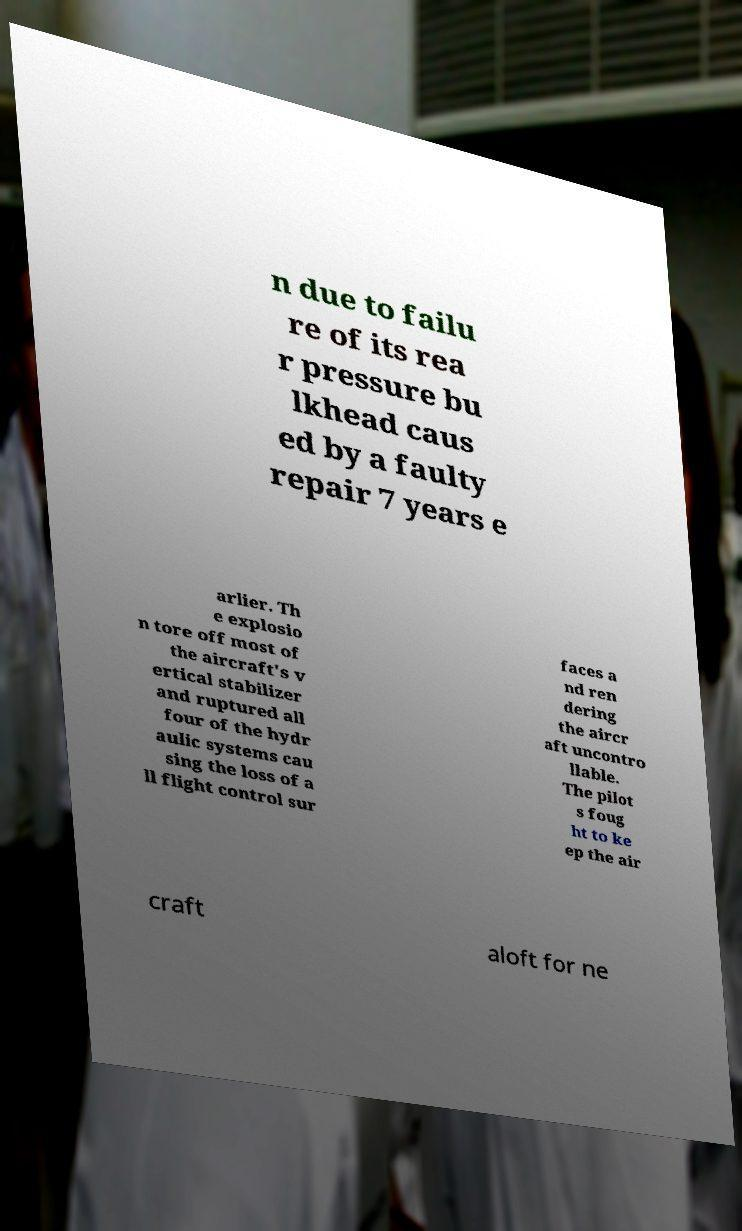I need the written content from this picture converted into text. Can you do that? n due to failu re of its rea r pressure bu lkhead caus ed by a faulty repair 7 years e arlier. Th e explosio n tore off most of the aircraft's v ertical stabilizer and ruptured all four of the hydr aulic systems cau sing the loss of a ll flight control sur faces a nd ren dering the aircr aft uncontro llable. The pilot s foug ht to ke ep the air craft aloft for ne 